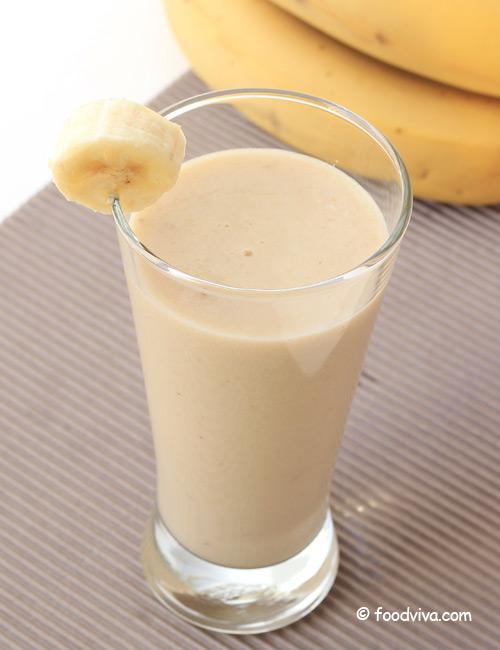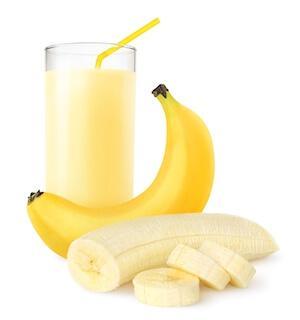The first image is the image on the left, the second image is the image on the right. Evaluate the accuracy of this statement regarding the images: "The left image contains one smoothie with a small banana slice in the rim of its glass.". Is it true? Answer yes or no. Yes. The first image is the image on the left, the second image is the image on the right. Analyze the images presented: Is the assertion "An image includes a smoothie in a glass with a straw and garnish, in front of a bunch of bananas." valid? Answer yes or no. No. 